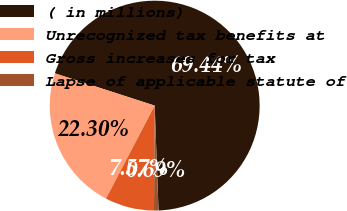Convert chart. <chart><loc_0><loc_0><loc_500><loc_500><pie_chart><fcel>( in millions)<fcel>Unrecognized tax benefits at<fcel>Gross increases for tax<fcel>Lapse of applicable statute of<nl><fcel>69.44%<fcel>22.3%<fcel>7.57%<fcel>0.69%<nl></chart> 